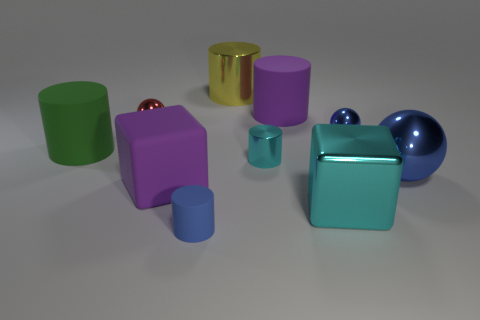Subtract all small spheres. How many spheres are left? 1 Subtract all balls. How many objects are left? 7 Subtract all cyan blocks. How many blocks are left? 1 Subtract 0 yellow cubes. How many objects are left? 10 Subtract 1 balls. How many balls are left? 2 Subtract all brown spheres. Subtract all blue cubes. How many spheres are left? 3 Subtract all green spheres. How many purple cylinders are left? 1 Subtract all blue spheres. Subtract all big red shiny balls. How many objects are left? 8 Add 9 metallic blocks. How many metallic blocks are left? 10 Add 5 large purple cylinders. How many large purple cylinders exist? 6 